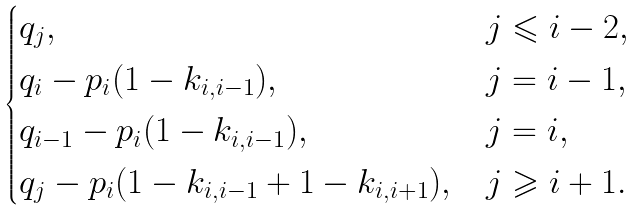Convert formula to latex. <formula><loc_0><loc_0><loc_500><loc_500>\begin{cases} q _ { j } , & j \leqslant i - 2 , \\ q _ { i } - p _ { i } ( 1 - k _ { i , i - 1 } ) , & j = i - 1 , \\ q _ { i - 1 } - p _ { i } ( 1 - k _ { i , i - 1 } ) , & j = i , \\ q _ { j } - p _ { i } ( 1 - k _ { i , i - 1 } + 1 - k _ { i , i + 1 } ) , & j \geqslant i + 1 . \end{cases}</formula> 